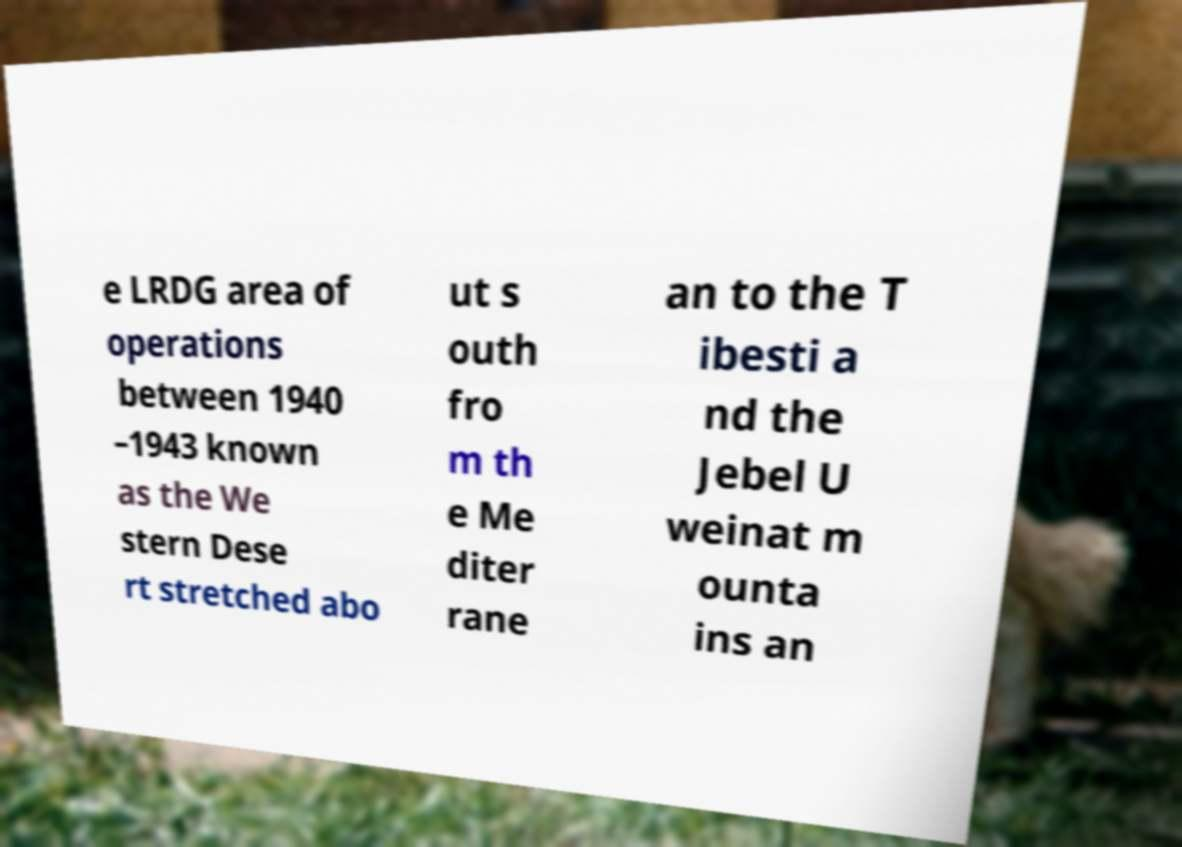Can you accurately transcribe the text from the provided image for me? e LRDG area of operations between 1940 –1943 known as the We stern Dese rt stretched abo ut s outh fro m th e Me diter rane an to the T ibesti a nd the Jebel U weinat m ounta ins an 